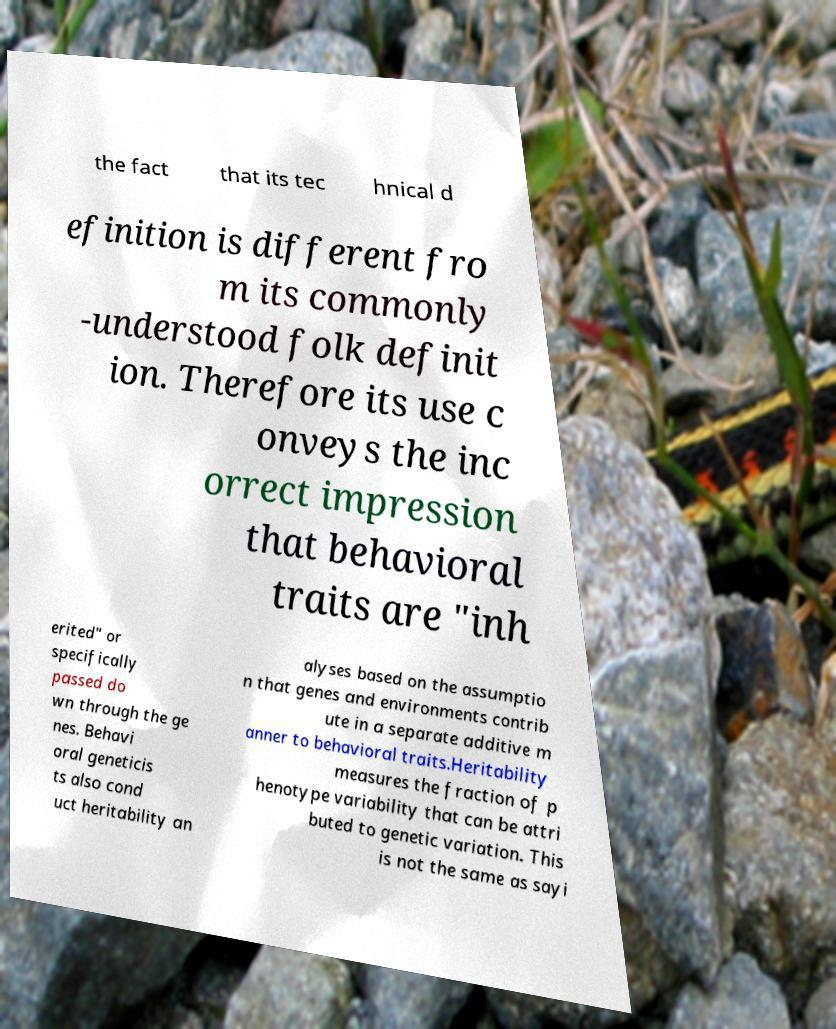What messages or text are displayed in this image? I need them in a readable, typed format. the fact that its tec hnical d efinition is different fro m its commonly -understood folk definit ion. Therefore its use c onveys the inc orrect impression that behavioral traits are "inh erited" or specifically passed do wn through the ge nes. Behavi oral geneticis ts also cond uct heritability an alyses based on the assumptio n that genes and environments contrib ute in a separate additive m anner to behavioral traits.Heritability measures the fraction of p henotype variability that can be attri buted to genetic variation. This is not the same as sayi 